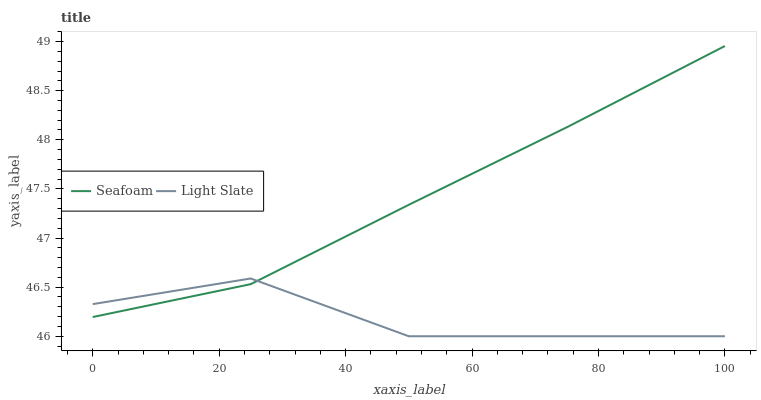Does Light Slate have the minimum area under the curve?
Answer yes or no. Yes. Does Seafoam have the maximum area under the curve?
Answer yes or no. Yes. Does Seafoam have the minimum area under the curve?
Answer yes or no. No. Is Seafoam the smoothest?
Answer yes or no. Yes. Is Light Slate the roughest?
Answer yes or no. Yes. Is Seafoam the roughest?
Answer yes or no. No. Does Seafoam have the lowest value?
Answer yes or no. No. Does Seafoam have the highest value?
Answer yes or no. Yes. Does Light Slate intersect Seafoam?
Answer yes or no. Yes. Is Light Slate less than Seafoam?
Answer yes or no. No. Is Light Slate greater than Seafoam?
Answer yes or no. No. 